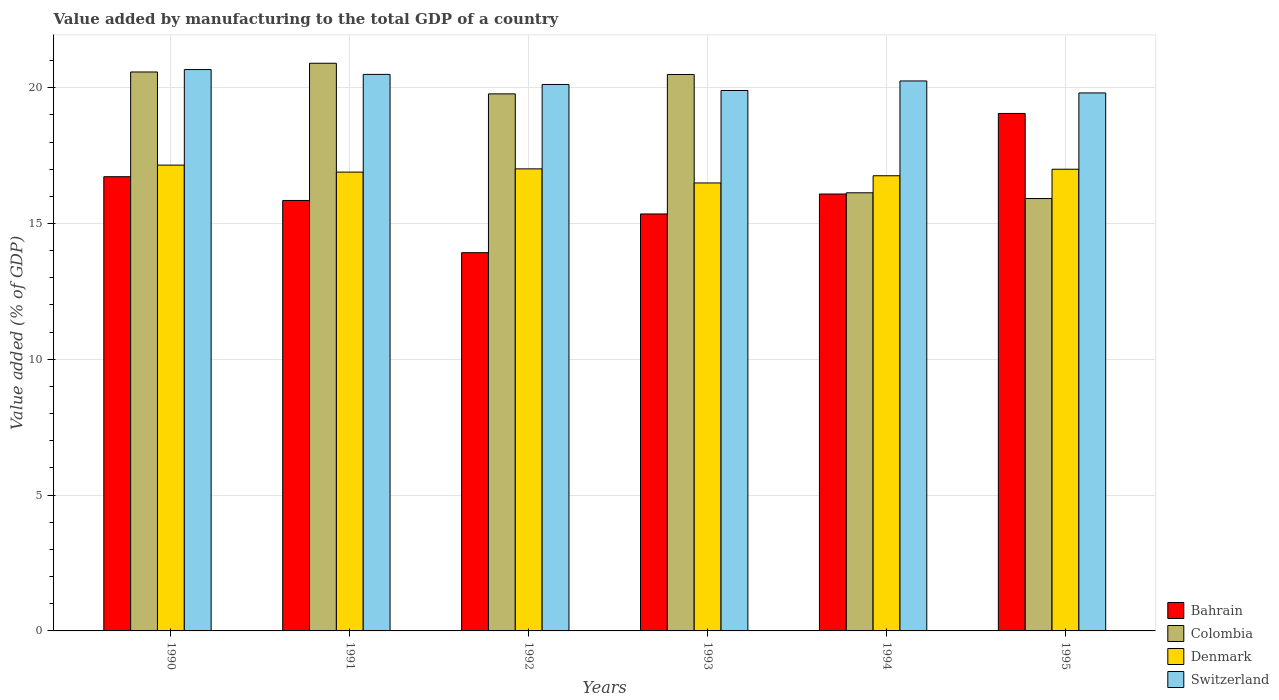Are the number of bars on each tick of the X-axis equal?
Offer a terse response. Yes. What is the label of the 4th group of bars from the left?
Provide a short and direct response. 1993. What is the value added by manufacturing to the total GDP in Denmark in 1990?
Your answer should be compact. 17.15. Across all years, what is the maximum value added by manufacturing to the total GDP in Switzerland?
Offer a terse response. 20.67. Across all years, what is the minimum value added by manufacturing to the total GDP in Switzerland?
Your response must be concise. 19.81. In which year was the value added by manufacturing to the total GDP in Colombia maximum?
Provide a succinct answer. 1991. In which year was the value added by manufacturing to the total GDP in Switzerland minimum?
Offer a very short reply. 1995. What is the total value added by manufacturing to the total GDP in Denmark in the graph?
Your response must be concise. 101.3. What is the difference between the value added by manufacturing to the total GDP in Colombia in 1990 and that in 1991?
Offer a very short reply. -0.32. What is the difference between the value added by manufacturing to the total GDP in Colombia in 1992 and the value added by manufacturing to the total GDP in Denmark in 1994?
Your response must be concise. 3.01. What is the average value added by manufacturing to the total GDP in Switzerland per year?
Make the answer very short. 20.21. In the year 1995, what is the difference between the value added by manufacturing to the total GDP in Denmark and value added by manufacturing to the total GDP in Colombia?
Offer a very short reply. 1.08. What is the ratio of the value added by manufacturing to the total GDP in Denmark in 1990 to that in 1994?
Provide a succinct answer. 1.02. Is the value added by manufacturing to the total GDP in Bahrain in 1990 less than that in 1993?
Make the answer very short. No. What is the difference between the highest and the second highest value added by manufacturing to the total GDP in Bahrain?
Offer a very short reply. 2.33. What is the difference between the highest and the lowest value added by manufacturing to the total GDP in Denmark?
Your answer should be very brief. 0.66. In how many years, is the value added by manufacturing to the total GDP in Bahrain greater than the average value added by manufacturing to the total GDP in Bahrain taken over all years?
Your answer should be compact. 2. Is the sum of the value added by manufacturing to the total GDP in Denmark in 1990 and 1993 greater than the maximum value added by manufacturing to the total GDP in Switzerland across all years?
Ensure brevity in your answer.  Yes. Is it the case that in every year, the sum of the value added by manufacturing to the total GDP in Colombia and value added by manufacturing to the total GDP in Switzerland is greater than the sum of value added by manufacturing to the total GDP in Denmark and value added by manufacturing to the total GDP in Bahrain?
Keep it short and to the point. No. What does the 1st bar from the left in 1991 represents?
Provide a short and direct response. Bahrain. What does the 1st bar from the right in 1992 represents?
Offer a terse response. Switzerland. Is it the case that in every year, the sum of the value added by manufacturing to the total GDP in Colombia and value added by manufacturing to the total GDP in Denmark is greater than the value added by manufacturing to the total GDP in Switzerland?
Offer a very short reply. Yes. How many bars are there?
Offer a very short reply. 24. How many years are there in the graph?
Make the answer very short. 6. Does the graph contain grids?
Ensure brevity in your answer.  Yes. What is the title of the graph?
Provide a short and direct response. Value added by manufacturing to the total GDP of a country. What is the label or title of the Y-axis?
Provide a succinct answer. Value added (% of GDP). What is the Value added (% of GDP) in Bahrain in 1990?
Your answer should be compact. 16.72. What is the Value added (% of GDP) in Colombia in 1990?
Keep it short and to the point. 20.58. What is the Value added (% of GDP) of Denmark in 1990?
Provide a short and direct response. 17.15. What is the Value added (% of GDP) of Switzerland in 1990?
Give a very brief answer. 20.67. What is the Value added (% of GDP) in Bahrain in 1991?
Provide a short and direct response. 15.85. What is the Value added (% of GDP) of Colombia in 1991?
Make the answer very short. 20.9. What is the Value added (% of GDP) in Denmark in 1991?
Your answer should be very brief. 16.89. What is the Value added (% of GDP) of Switzerland in 1991?
Your response must be concise. 20.49. What is the Value added (% of GDP) of Bahrain in 1992?
Offer a very short reply. 13.93. What is the Value added (% of GDP) of Colombia in 1992?
Keep it short and to the point. 19.77. What is the Value added (% of GDP) in Denmark in 1992?
Ensure brevity in your answer.  17.01. What is the Value added (% of GDP) of Switzerland in 1992?
Your answer should be very brief. 20.12. What is the Value added (% of GDP) of Bahrain in 1993?
Your answer should be very brief. 15.35. What is the Value added (% of GDP) in Colombia in 1993?
Offer a very short reply. 20.49. What is the Value added (% of GDP) of Denmark in 1993?
Ensure brevity in your answer.  16.49. What is the Value added (% of GDP) in Switzerland in 1993?
Your answer should be very brief. 19.9. What is the Value added (% of GDP) in Bahrain in 1994?
Your answer should be compact. 16.09. What is the Value added (% of GDP) of Colombia in 1994?
Provide a short and direct response. 16.13. What is the Value added (% of GDP) in Denmark in 1994?
Your response must be concise. 16.76. What is the Value added (% of GDP) of Switzerland in 1994?
Offer a very short reply. 20.25. What is the Value added (% of GDP) in Bahrain in 1995?
Keep it short and to the point. 19.05. What is the Value added (% of GDP) of Colombia in 1995?
Provide a short and direct response. 15.92. What is the Value added (% of GDP) in Denmark in 1995?
Ensure brevity in your answer.  17. What is the Value added (% of GDP) in Switzerland in 1995?
Provide a short and direct response. 19.81. Across all years, what is the maximum Value added (% of GDP) of Bahrain?
Provide a succinct answer. 19.05. Across all years, what is the maximum Value added (% of GDP) in Colombia?
Your response must be concise. 20.9. Across all years, what is the maximum Value added (% of GDP) in Denmark?
Your answer should be compact. 17.15. Across all years, what is the maximum Value added (% of GDP) of Switzerland?
Provide a succinct answer. 20.67. Across all years, what is the minimum Value added (% of GDP) in Bahrain?
Your answer should be compact. 13.93. Across all years, what is the minimum Value added (% of GDP) of Colombia?
Offer a very short reply. 15.92. Across all years, what is the minimum Value added (% of GDP) of Denmark?
Offer a very short reply. 16.49. Across all years, what is the minimum Value added (% of GDP) in Switzerland?
Your answer should be very brief. 19.81. What is the total Value added (% of GDP) of Bahrain in the graph?
Make the answer very short. 96.99. What is the total Value added (% of GDP) in Colombia in the graph?
Your response must be concise. 113.79. What is the total Value added (% of GDP) of Denmark in the graph?
Make the answer very short. 101.31. What is the total Value added (% of GDP) of Switzerland in the graph?
Your response must be concise. 121.23. What is the difference between the Value added (% of GDP) of Bahrain in 1990 and that in 1991?
Keep it short and to the point. 0.87. What is the difference between the Value added (% of GDP) in Colombia in 1990 and that in 1991?
Provide a short and direct response. -0.32. What is the difference between the Value added (% of GDP) in Denmark in 1990 and that in 1991?
Your answer should be compact. 0.26. What is the difference between the Value added (% of GDP) of Switzerland in 1990 and that in 1991?
Make the answer very short. 0.18. What is the difference between the Value added (% of GDP) in Bahrain in 1990 and that in 1992?
Provide a short and direct response. 2.8. What is the difference between the Value added (% of GDP) of Colombia in 1990 and that in 1992?
Make the answer very short. 0.81. What is the difference between the Value added (% of GDP) in Denmark in 1990 and that in 1992?
Your answer should be compact. 0.14. What is the difference between the Value added (% of GDP) in Switzerland in 1990 and that in 1992?
Ensure brevity in your answer.  0.55. What is the difference between the Value added (% of GDP) of Bahrain in 1990 and that in 1993?
Offer a very short reply. 1.37. What is the difference between the Value added (% of GDP) of Colombia in 1990 and that in 1993?
Provide a succinct answer. 0.09. What is the difference between the Value added (% of GDP) in Denmark in 1990 and that in 1993?
Provide a succinct answer. 0.66. What is the difference between the Value added (% of GDP) of Switzerland in 1990 and that in 1993?
Your response must be concise. 0.77. What is the difference between the Value added (% of GDP) of Bahrain in 1990 and that in 1994?
Provide a succinct answer. 0.64. What is the difference between the Value added (% of GDP) of Colombia in 1990 and that in 1994?
Offer a terse response. 4.45. What is the difference between the Value added (% of GDP) in Denmark in 1990 and that in 1994?
Give a very brief answer. 0.39. What is the difference between the Value added (% of GDP) in Switzerland in 1990 and that in 1994?
Ensure brevity in your answer.  0.42. What is the difference between the Value added (% of GDP) in Bahrain in 1990 and that in 1995?
Ensure brevity in your answer.  -2.33. What is the difference between the Value added (% of GDP) in Colombia in 1990 and that in 1995?
Keep it short and to the point. 4.66. What is the difference between the Value added (% of GDP) of Denmark in 1990 and that in 1995?
Your response must be concise. 0.15. What is the difference between the Value added (% of GDP) of Switzerland in 1990 and that in 1995?
Your answer should be compact. 0.86. What is the difference between the Value added (% of GDP) in Bahrain in 1991 and that in 1992?
Your response must be concise. 1.92. What is the difference between the Value added (% of GDP) of Colombia in 1991 and that in 1992?
Provide a succinct answer. 1.13. What is the difference between the Value added (% of GDP) of Denmark in 1991 and that in 1992?
Your response must be concise. -0.12. What is the difference between the Value added (% of GDP) in Switzerland in 1991 and that in 1992?
Your answer should be very brief. 0.37. What is the difference between the Value added (% of GDP) of Bahrain in 1991 and that in 1993?
Offer a very short reply. 0.5. What is the difference between the Value added (% of GDP) in Colombia in 1991 and that in 1993?
Give a very brief answer. 0.41. What is the difference between the Value added (% of GDP) in Denmark in 1991 and that in 1993?
Ensure brevity in your answer.  0.4. What is the difference between the Value added (% of GDP) in Switzerland in 1991 and that in 1993?
Provide a succinct answer. 0.59. What is the difference between the Value added (% of GDP) in Bahrain in 1991 and that in 1994?
Provide a short and direct response. -0.24. What is the difference between the Value added (% of GDP) in Colombia in 1991 and that in 1994?
Make the answer very short. 4.77. What is the difference between the Value added (% of GDP) of Denmark in 1991 and that in 1994?
Offer a terse response. 0.13. What is the difference between the Value added (% of GDP) in Switzerland in 1991 and that in 1994?
Provide a short and direct response. 0.24. What is the difference between the Value added (% of GDP) of Bahrain in 1991 and that in 1995?
Your answer should be compact. -3.2. What is the difference between the Value added (% of GDP) in Colombia in 1991 and that in 1995?
Provide a short and direct response. 4.98. What is the difference between the Value added (% of GDP) of Denmark in 1991 and that in 1995?
Make the answer very short. -0.11. What is the difference between the Value added (% of GDP) in Switzerland in 1991 and that in 1995?
Provide a short and direct response. 0.68. What is the difference between the Value added (% of GDP) of Bahrain in 1992 and that in 1993?
Give a very brief answer. -1.43. What is the difference between the Value added (% of GDP) of Colombia in 1992 and that in 1993?
Your response must be concise. -0.71. What is the difference between the Value added (% of GDP) in Denmark in 1992 and that in 1993?
Ensure brevity in your answer.  0.52. What is the difference between the Value added (% of GDP) in Switzerland in 1992 and that in 1993?
Offer a terse response. 0.22. What is the difference between the Value added (% of GDP) in Bahrain in 1992 and that in 1994?
Provide a short and direct response. -2.16. What is the difference between the Value added (% of GDP) of Colombia in 1992 and that in 1994?
Ensure brevity in your answer.  3.64. What is the difference between the Value added (% of GDP) in Denmark in 1992 and that in 1994?
Give a very brief answer. 0.25. What is the difference between the Value added (% of GDP) in Switzerland in 1992 and that in 1994?
Make the answer very short. -0.13. What is the difference between the Value added (% of GDP) of Bahrain in 1992 and that in 1995?
Your answer should be very brief. -5.13. What is the difference between the Value added (% of GDP) in Colombia in 1992 and that in 1995?
Give a very brief answer. 3.85. What is the difference between the Value added (% of GDP) in Denmark in 1992 and that in 1995?
Offer a very short reply. 0.01. What is the difference between the Value added (% of GDP) of Switzerland in 1992 and that in 1995?
Keep it short and to the point. 0.31. What is the difference between the Value added (% of GDP) in Bahrain in 1993 and that in 1994?
Your response must be concise. -0.73. What is the difference between the Value added (% of GDP) in Colombia in 1993 and that in 1994?
Provide a succinct answer. 4.36. What is the difference between the Value added (% of GDP) in Denmark in 1993 and that in 1994?
Provide a succinct answer. -0.26. What is the difference between the Value added (% of GDP) of Switzerland in 1993 and that in 1994?
Make the answer very short. -0.35. What is the difference between the Value added (% of GDP) of Bahrain in 1993 and that in 1995?
Your response must be concise. -3.7. What is the difference between the Value added (% of GDP) of Colombia in 1993 and that in 1995?
Offer a very short reply. 4.57. What is the difference between the Value added (% of GDP) of Denmark in 1993 and that in 1995?
Keep it short and to the point. -0.51. What is the difference between the Value added (% of GDP) in Switzerland in 1993 and that in 1995?
Keep it short and to the point. 0.09. What is the difference between the Value added (% of GDP) of Bahrain in 1994 and that in 1995?
Provide a succinct answer. -2.97. What is the difference between the Value added (% of GDP) of Colombia in 1994 and that in 1995?
Your response must be concise. 0.21. What is the difference between the Value added (% of GDP) in Denmark in 1994 and that in 1995?
Keep it short and to the point. -0.24. What is the difference between the Value added (% of GDP) of Switzerland in 1994 and that in 1995?
Your response must be concise. 0.44. What is the difference between the Value added (% of GDP) of Bahrain in 1990 and the Value added (% of GDP) of Colombia in 1991?
Your answer should be very brief. -4.18. What is the difference between the Value added (% of GDP) of Bahrain in 1990 and the Value added (% of GDP) of Denmark in 1991?
Your response must be concise. -0.17. What is the difference between the Value added (% of GDP) in Bahrain in 1990 and the Value added (% of GDP) in Switzerland in 1991?
Your answer should be compact. -3.77. What is the difference between the Value added (% of GDP) of Colombia in 1990 and the Value added (% of GDP) of Denmark in 1991?
Your answer should be compact. 3.69. What is the difference between the Value added (% of GDP) of Colombia in 1990 and the Value added (% of GDP) of Switzerland in 1991?
Your answer should be compact. 0.09. What is the difference between the Value added (% of GDP) of Denmark in 1990 and the Value added (% of GDP) of Switzerland in 1991?
Keep it short and to the point. -3.34. What is the difference between the Value added (% of GDP) of Bahrain in 1990 and the Value added (% of GDP) of Colombia in 1992?
Make the answer very short. -3.05. What is the difference between the Value added (% of GDP) in Bahrain in 1990 and the Value added (% of GDP) in Denmark in 1992?
Make the answer very short. -0.29. What is the difference between the Value added (% of GDP) of Bahrain in 1990 and the Value added (% of GDP) of Switzerland in 1992?
Your response must be concise. -3.4. What is the difference between the Value added (% of GDP) of Colombia in 1990 and the Value added (% of GDP) of Denmark in 1992?
Keep it short and to the point. 3.57. What is the difference between the Value added (% of GDP) in Colombia in 1990 and the Value added (% of GDP) in Switzerland in 1992?
Your response must be concise. 0.46. What is the difference between the Value added (% of GDP) in Denmark in 1990 and the Value added (% of GDP) in Switzerland in 1992?
Offer a very short reply. -2.97. What is the difference between the Value added (% of GDP) of Bahrain in 1990 and the Value added (% of GDP) of Colombia in 1993?
Provide a succinct answer. -3.76. What is the difference between the Value added (% of GDP) in Bahrain in 1990 and the Value added (% of GDP) in Denmark in 1993?
Keep it short and to the point. 0.23. What is the difference between the Value added (% of GDP) in Bahrain in 1990 and the Value added (% of GDP) in Switzerland in 1993?
Offer a terse response. -3.17. What is the difference between the Value added (% of GDP) of Colombia in 1990 and the Value added (% of GDP) of Denmark in 1993?
Provide a short and direct response. 4.09. What is the difference between the Value added (% of GDP) of Colombia in 1990 and the Value added (% of GDP) of Switzerland in 1993?
Give a very brief answer. 0.68. What is the difference between the Value added (% of GDP) of Denmark in 1990 and the Value added (% of GDP) of Switzerland in 1993?
Keep it short and to the point. -2.75. What is the difference between the Value added (% of GDP) in Bahrain in 1990 and the Value added (% of GDP) in Colombia in 1994?
Provide a short and direct response. 0.59. What is the difference between the Value added (% of GDP) of Bahrain in 1990 and the Value added (% of GDP) of Denmark in 1994?
Provide a succinct answer. -0.04. What is the difference between the Value added (% of GDP) in Bahrain in 1990 and the Value added (% of GDP) in Switzerland in 1994?
Your answer should be very brief. -3.53. What is the difference between the Value added (% of GDP) of Colombia in 1990 and the Value added (% of GDP) of Denmark in 1994?
Offer a very short reply. 3.82. What is the difference between the Value added (% of GDP) in Colombia in 1990 and the Value added (% of GDP) in Switzerland in 1994?
Your answer should be compact. 0.33. What is the difference between the Value added (% of GDP) of Denmark in 1990 and the Value added (% of GDP) of Switzerland in 1994?
Offer a terse response. -3.1. What is the difference between the Value added (% of GDP) of Bahrain in 1990 and the Value added (% of GDP) of Colombia in 1995?
Offer a terse response. 0.8. What is the difference between the Value added (% of GDP) in Bahrain in 1990 and the Value added (% of GDP) in Denmark in 1995?
Provide a succinct answer. -0.28. What is the difference between the Value added (% of GDP) in Bahrain in 1990 and the Value added (% of GDP) in Switzerland in 1995?
Your response must be concise. -3.08. What is the difference between the Value added (% of GDP) of Colombia in 1990 and the Value added (% of GDP) of Denmark in 1995?
Your answer should be very brief. 3.58. What is the difference between the Value added (% of GDP) in Colombia in 1990 and the Value added (% of GDP) in Switzerland in 1995?
Provide a succinct answer. 0.77. What is the difference between the Value added (% of GDP) of Denmark in 1990 and the Value added (% of GDP) of Switzerland in 1995?
Provide a short and direct response. -2.66. What is the difference between the Value added (% of GDP) in Bahrain in 1991 and the Value added (% of GDP) in Colombia in 1992?
Ensure brevity in your answer.  -3.92. What is the difference between the Value added (% of GDP) in Bahrain in 1991 and the Value added (% of GDP) in Denmark in 1992?
Provide a succinct answer. -1.16. What is the difference between the Value added (% of GDP) in Bahrain in 1991 and the Value added (% of GDP) in Switzerland in 1992?
Offer a very short reply. -4.27. What is the difference between the Value added (% of GDP) of Colombia in 1991 and the Value added (% of GDP) of Denmark in 1992?
Provide a succinct answer. 3.89. What is the difference between the Value added (% of GDP) of Colombia in 1991 and the Value added (% of GDP) of Switzerland in 1992?
Keep it short and to the point. 0.78. What is the difference between the Value added (% of GDP) of Denmark in 1991 and the Value added (% of GDP) of Switzerland in 1992?
Give a very brief answer. -3.23. What is the difference between the Value added (% of GDP) of Bahrain in 1991 and the Value added (% of GDP) of Colombia in 1993?
Your answer should be very brief. -4.64. What is the difference between the Value added (% of GDP) in Bahrain in 1991 and the Value added (% of GDP) in Denmark in 1993?
Make the answer very short. -0.64. What is the difference between the Value added (% of GDP) of Bahrain in 1991 and the Value added (% of GDP) of Switzerland in 1993?
Make the answer very short. -4.05. What is the difference between the Value added (% of GDP) in Colombia in 1991 and the Value added (% of GDP) in Denmark in 1993?
Ensure brevity in your answer.  4.41. What is the difference between the Value added (% of GDP) in Colombia in 1991 and the Value added (% of GDP) in Switzerland in 1993?
Ensure brevity in your answer.  1. What is the difference between the Value added (% of GDP) of Denmark in 1991 and the Value added (% of GDP) of Switzerland in 1993?
Ensure brevity in your answer.  -3. What is the difference between the Value added (% of GDP) in Bahrain in 1991 and the Value added (% of GDP) in Colombia in 1994?
Make the answer very short. -0.28. What is the difference between the Value added (% of GDP) in Bahrain in 1991 and the Value added (% of GDP) in Denmark in 1994?
Keep it short and to the point. -0.91. What is the difference between the Value added (% of GDP) in Bahrain in 1991 and the Value added (% of GDP) in Switzerland in 1994?
Offer a terse response. -4.4. What is the difference between the Value added (% of GDP) in Colombia in 1991 and the Value added (% of GDP) in Denmark in 1994?
Your answer should be compact. 4.14. What is the difference between the Value added (% of GDP) in Colombia in 1991 and the Value added (% of GDP) in Switzerland in 1994?
Keep it short and to the point. 0.65. What is the difference between the Value added (% of GDP) in Denmark in 1991 and the Value added (% of GDP) in Switzerland in 1994?
Your answer should be very brief. -3.36. What is the difference between the Value added (% of GDP) of Bahrain in 1991 and the Value added (% of GDP) of Colombia in 1995?
Your response must be concise. -0.07. What is the difference between the Value added (% of GDP) in Bahrain in 1991 and the Value added (% of GDP) in Denmark in 1995?
Offer a very short reply. -1.15. What is the difference between the Value added (% of GDP) of Bahrain in 1991 and the Value added (% of GDP) of Switzerland in 1995?
Make the answer very short. -3.96. What is the difference between the Value added (% of GDP) in Colombia in 1991 and the Value added (% of GDP) in Denmark in 1995?
Your response must be concise. 3.9. What is the difference between the Value added (% of GDP) of Colombia in 1991 and the Value added (% of GDP) of Switzerland in 1995?
Provide a short and direct response. 1.09. What is the difference between the Value added (% of GDP) of Denmark in 1991 and the Value added (% of GDP) of Switzerland in 1995?
Provide a short and direct response. -2.91. What is the difference between the Value added (% of GDP) in Bahrain in 1992 and the Value added (% of GDP) in Colombia in 1993?
Offer a very short reply. -6.56. What is the difference between the Value added (% of GDP) of Bahrain in 1992 and the Value added (% of GDP) of Denmark in 1993?
Your answer should be compact. -2.57. What is the difference between the Value added (% of GDP) of Bahrain in 1992 and the Value added (% of GDP) of Switzerland in 1993?
Provide a short and direct response. -5.97. What is the difference between the Value added (% of GDP) in Colombia in 1992 and the Value added (% of GDP) in Denmark in 1993?
Provide a short and direct response. 3.28. What is the difference between the Value added (% of GDP) of Colombia in 1992 and the Value added (% of GDP) of Switzerland in 1993?
Offer a terse response. -0.12. What is the difference between the Value added (% of GDP) of Denmark in 1992 and the Value added (% of GDP) of Switzerland in 1993?
Provide a short and direct response. -2.89. What is the difference between the Value added (% of GDP) of Bahrain in 1992 and the Value added (% of GDP) of Colombia in 1994?
Offer a terse response. -2.21. What is the difference between the Value added (% of GDP) of Bahrain in 1992 and the Value added (% of GDP) of Denmark in 1994?
Offer a terse response. -2.83. What is the difference between the Value added (% of GDP) in Bahrain in 1992 and the Value added (% of GDP) in Switzerland in 1994?
Provide a succinct answer. -6.32. What is the difference between the Value added (% of GDP) in Colombia in 1992 and the Value added (% of GDP) in Denmark in 1994?
Ensure brevity in your answer.  3.01. What is the difference between the Value added (% of GDP) in Colombia in 1992 and the Value added (% of GDP) in Switzerland in 1994?
Keep it short and to the point. -0.48. What is the difference between the Value added (% of GDP) in Denmark in 1992 and the Value added (% of GDP) in Switzerland in 1994?
Ensure brevity in your answer.  -3.24. What is the difference between the Value added (% of GDP) of Bahrain in 1992 and the Value added (% of GDP) of Colombia in 1995?
Make the answer very short. -1.99. What is the difference between the Value added (% of GDP) of Bahrain in 1992 and the Value added (% of GDP) of Denmark in 1995?
Your response must be concise. -3.07. What is the difference between the Value added (% of GDP) in Bahrain in 1992 and the Value added (% of GDP) in Switzerland in 1995?
Your answer should be very brief. -5.88. What is the difference between the Value added (% of GDP) in Colombia in 1992 and the Value added (% of GDP) in Denmark in 1995?
Provide a succinct answer. 2.77. What is the difference between the Value added (% of GDP) of Colombia in 1992 and the Value added (% of GDP) of Switzerland in 1995?
Keep it short and to the point. -0.03. What is the difference between the Value added (% of GDP) in Denmark in 1992 and the Value added (% of GDP) in Switzerland in 1995?
Your answer should be very brief. -2.8. What is the difference between the Value added (% of GDP) of Bahrain in 1993 and the Value added (% of GDP) of Colombia in 1994?
Your answer should be very brief. -0.78. What is the difference between the Value added (% of GDP) in Bahrain in 1993 and the Value added (% of GDP) in Denmark in 1994?
Provide a succinct answer. -1.41. What is the difference between the Value added (% of GDP) in Bahrain in 1993 and the Value added (% of GDP) in Switzerland in 1994?
Your answer should be very brief. -4.9. What is the difference between the Value added (% of GDP) of Colombia in 1993 and the Value added (% of GDP) of Denmark in 1994?
Offer a very short reply. 3.73. What is the difference between the Value added (% of GDP) of Colombia in 1993 and the Value added (% of GDP) of Switzerland in 1994?
Give a very brief answer. 0.24. What is the difference between the Value added (% of GDP) of Denmark in 1993 and the Value added (% of GDP) of Switzerland in 1994?
Make the answer very short. -3.76. What is the difference between the Value added (% of GDP) of Bahrain in 1993 and the Value added (% of GDP) of Colombia in 1995?
Your answer should be compact. -0.57. What is the difference between the Value added (% of GDP) of Bahrain in 1993 and the Value added (% of GDP) of Denmark in 1995?
Your answer should be very brief. -1.65. What is the difference between the Value added (% of GDP) in Bahrain in 1993 and the Value added (% of GDP) in Switzerland in 1995?
Offer a very short reply. -4.46. What is the difference between the Value added (% of GDP) in Colombia in 1993 and the Value added (% of GDP) in Denmark in 1995?
Your answer should be very brief. 3.49. What is the difference between the Value added (% of GDP) in Colombia in 1993 and the Value added (% of GDP) in Switzerland in 1995?
Provide a succinct answer. 0.68. What is the difference between the Value added (% of GDP) in Denmark in 1993 and the Value added (% of GDP) in Switzerland in 1995?
Offer a terse response. -3.31. What is the difference between the Value added (% of GDP) of Bahrain in 1994 and the Value added (% of GDP) of Colombia in 1995?
Give a very brief answer. 0.17. What is the difference between the Value added (% of GDP) of Bahrain in 1994 and the Value added (% of GDP) of Denmark in 1995?
Provide a short and direct response. -0.91. What is the difference between the Value added (% of GDP) in Bahrain in 1994 and the Value added (% of GDP) in Switzerland in 1995?
Offer a terse response. -3.72. What is the difference between the Value added (% of GDP) of Colombia in 1994 and the Value added (% of GDP) of Denmark in 1995?
Your answer should be very brief. -0.87. What is the difference between the Value added (% of GDP) in Colombia in 1994 and the Value added (% of GDP) in Switzerland in 1995?
Provide a succinct answer. -3.68. What is the difference between the Value added (% of GDP) of Denmark in 1994 and the Value added (% of GDP) of Switzerland in 1995?
Offer a very short reply. -3.05. What is the average Value added (% of GDP) in Bahrain per year?
Your answer should be compact. 16.16. What is the average Value added (% of GDP) of Colombia per year?
Offer a very short reply. 18.96. What is the average Value added (% of GDP) in Denmark per year?
Offer a terse response. 16.88. What is the average Value added (% of GDP) of Switzerland per year?
Offer a terse response. 20.21. In the year 1990, what is the difference between the Value added (% of GDP) of Bahrain and Value added (% of GDP) of Colombia?
Your answer should be compact. -3.86. In the year 1990, what is the difference between the Value added (% of GDP) of Bahrain and Value added (% of GDP) of Denmark?
Provide a short and direct response. -0.43. In the year 1990, what is the difference between the Value added (% of GDP) in Bahrain and Value added (% of GDP) in Switzerland?
Provide a succinct answer. -3.95. In the year 1990, what is the difference between the Value added (% of GDP) in Colombia and Value added (% of GDP) in Denmark?
Your response must be concise. 3.43. In the year 1990, what is the difference between the Value added (% of GDP) in Colombia and Value added (% of GDP) in Switzerland?
Make the answer very short. -0.09. In the year 1990, what is the difference between the Value added (% of GDP) of Denmark and Value added (% of GDP) of Switzerland?
Your response must be concise. -3.52. In the year 1991, what is the difference between the Value added (% of GDP) of Bahrain and Value added (% of GDP) of Colombia?
Your answer should be very brief. -5.05. In the year 1991, what is the difference between the Value added (% of GDP) in Bahrain and Value added (% of GDP) in Denmark?
Provide a succinct answer. -1.04. In the year 1991, what is the difference between the Value added (% of GDP) of Bahrain and Value added (% of GDP) of Switzerland?
Offer a terse response. -4.64. In the year 1991, what is the difference between the Value added (% of GDP) of Colombia and Value added (% of GDP) of Denmark?
Your response must be concise. 4.01. In the year 1991, what is the difference between the Value added (% of GDP) of Colombia and Value added (% of GDP) of Switzerland?
Your answer should be very brief. 0.41. In the year 1991, what is the difference between the Value added (% of GDP) of Denmark and Value added (% of GDP) of Switzerland?
Offer a terse response. -3.6. In the year 1992, what is the difference between the Value added (% of GDP) of Bahrain and Value added (% of GDP) of Colombia?
Your answer should be very brief. -5.85. In the year 1992, what is the difference between the Value added (% of GDP) of Bahrain and Value added (% of GDP) of Denmark?
Provide a short and direct response. -3.09. In the year 1992, what is the difference between the Value added (% of GDP) of Bahrain and Value added (% of GDP) of Switzerland?
Give a very brief answer. -6.19. In the year 1992, what is the difference between the Value added (% of GDP) of Colombia and Value added (% of GDP) of Denmark?
Ensure brevity in your answer.  2.76. In the year 1992, what is the difference between the Value added (% of GDP) in Colombia and Value added (% of GDP) in Switzerland?
Provide a succinct answer. -0.35. In the year 1992, what is the difference between the Value added (% of GDP) in Denmark and Value added (% of GDP) in Switzerland?
Keep it short and to the point. -3.11. In the year 1993, what is the difference between the Value added (% of GDP) of Bahrain and Value added (% of GDP) of Colombia?
Keep it short and to the point. -5.14. In the year 1993, what is the difference between the Value added (% of GDP) of Bahrain and Value added (% of GDP) of Denmark?
Keep it short and to the point. -1.14. In the year 1993, what is the difference between the Value added (% of GDP) of Bahrain and Value added (% of GDP) of Switzerland?
Make the answer very short. -4.55. In the year 1993, what is the difference between the Value added (% of GDP) in Colombia and Value added (% of GDP) in Denmark?
Your response must be concise. 3.99. In the year 1993, what is the difference between the Value added (% of GDP) of Colombia and Value added (% of GDP) of Switzerland?
Keep it short and to the point. 0.59. In the year 1993, what is the difference between the Value added (% of GDP) of Denmark and Value added (% of GDP) of Switzerland?
Provide a succinct answer. -3.4. In the year 1994, what is the difference between the Value added (% of GDP) of Bahrain and Value added (% of GDP) of Colombia?
Offer a very short reply. -0.04. In the year 1994, what is the difference between the Value added (% of GDP) of Bahrain and Value added (% of GDP) of Denmark?
Make the answer very short. -0.67. In the year 1994, what is the difference between the Value added (% of GDP) in Bahrain and Value added (% of GDP) in Switzerland?
Your answer should be compact. -4.16. In the year 1994, what is the difference between the Value added (% of GDP) in Colombia and Value added (% of GDP) in Denmark?
Your response must be concise. -0.63. In the year 1994, what is the difference between the Value added (% of GDP) in Colombia and Value added (% of GDP) in Switzerland?
Keep it short and to the point. -4.12. In the year 1994, what is the difference between the Value added (% of GDP) in Denmark and Value added (% of GDP) in Switzerland?
Make the answer very short. -3.49. In the year 1995, what is the difference between the Value added (% of GDP) of Bahrain and Value added (% of GDP) of Colombia?
Keep it short and to the point. 3.13. In the year 1995, what is the difference between the Value added (% of GDP) of Bahrain and Value added (% of GDP) of Denmark?
Make the answer very short. 2.05. In the year 1995, what is the difference between the Value added (% of GDP) in Bahrain and Value added (% of GDP) in Switzerland?
Offer a very short reply. -0.76. In the year 1995, what is the difference between the Value added (% of GDP) of Colombia and Value added (% of GDP) of Denmark?
Your response must be concise. -1.08. In the year 1995, what is the difference between the Value added (% of GDP) in Colombia and Value added (% of GDP) in Switzerland?
Provide a succinct answer. -3.89. In the year 1995, what is the difference between the Value added (% of GDP) of Denmark and Value added (% of GDP) of Switzerland?
Make the answer very short. -2.81. What is the ratio of the Value added (% of GDP) in Bahrain in 1990 to that in 1991?
Make the answer very short. 1.06. What is the ratio of the Value added (% of GDP) of Colombia in 1990 to that in 1991?
Provide a short and direct response. 0.98. What is the ratio of the Value added (% of GDP) of Denmark in 1990 to that in 1991?
Offer a very short reply. 1.02. What is the ratio of the Value added (% of GDP) in Switzerland in 1990 to that in 1991?
Make the answer very short. 1.01. What is the ratio of the Value added (% of GDP) of Bahrain in 1990 to that in 1992?
Keep it short and to the point. 1.2. What is the ratio of the Value added (% of GDP) of Colombia in 1990 to that in 1992?
Offer a terse response. 1.04. What is the ratio of the Value added (% of GDP) of Switzerland in 1990 to that in 1992?
Offer a very short reply. 1.03. What is the ratio of the Value added (% of GDP) in Bahrain in 1990 to that in 1993?
Make the answer very short. 1.09. What is the ratio of the Value added (% of GDP) of Colombia in 1990 to that in 1993?
Your answer should be very brief. 1. What is the ratio of the Value added (% of GDP) in Denmark in 1990 to that in 1993?
Provide a succinct answer. 1.04. What is the ratio of the Value added (% of GDP) of Switzerland in 1990 to that in 1993?
Provide a short and direct response. 1.04. What is the ratio of the Value added (% of GDP) in Bahrain in 1990 to that in 1994?
Give a very brief answer. 1.04. What is the ratio of the Value added (% of GDP) of Colombia in 1990 to that in 1994?
Offer a terse response. 1.28. What is the ratio of the Value added (% of GDP) of Denmark in 1990 to that in 1994?
Provide a succinct answer. 1.02. What is the ratio of the Value added (% of GDP) of Switzerland in 1990 to that in 1994?
Your response must be concise. 1.02. What is the ratio of the Value added (% of GDP) of Bahrain in 1990 to that in 1995?
Your response must be concise. 0.88. What is the ratio of the Value added (% of GDP) of Colombia in 1990 to that in 1995?
Your response must be concise. 1.29. What is the ratio of the Value added (% of GDP) of Denmark in 1990 to that in 1995?
Your answer should be very brief. 1.01. What is the ratio of the Value added (% of GDP) of Switzerland in 1990 to that in 1995?
Give a very brief answer. 1.04. What is the ratio of the Value added (% of GDP) in Bahrain in 1991 to that in 1992?
Your response must be concise. 1.14. What is the ratio of the Value added (% of GDP) in Colombia in 1991 to that in 1992?
Offer a very short reply. 1.06. What is the ratio of the Value added (% of GDP) of Denmark in 1991 to that in 1992?
Your answer should be compact. 0.99. What is the ratio of the Value added (% of GDP) in Switzerland in 1991 to that in 1992?
Provide a succinct answer. 1.02. What is the ratio of the Value added (% of GDP) of Bahrain in 1991 to that in 1993?
Keep it short and to the point. 1.03. What is the ratio of the Value added (% of GDP) in Colombia in 1991 to that in 1993?
Keep it short and to the point. 1.02. What is the ratio of the Value added (% of GDP) in Denmark in 1991 to that in 1993?
Offer a very short reply. 1.02. What is the ratio of the Value added (% of GDP) of Switzerland in 1991 to that in 1993?
Offer a very short reply. 1.03. What is the ratio of the Value added (% of GDP) in Bahrain in 1991 to that in 1994?
Your answer should be compact. 0.99. What is the ratio of the Value added (% of GDP) of Colombia in 1991 to that in 1994?
Keep it short and to the point. 1.3. What is the ratio of the Value added (% of GDP) of Bahrain in 1991 to that in 1995?
Make the answer very short. 0.83. What is the ratio of the Value added (% of GDP) in Colombia in 1991 to that in 1995?
Your answer should be very brief. 1.31. What is the ratio of the Value added (% of GDP) of Switzerland in 1991 to that in 1995?
Your answer should be very brief. 1.03. What is the ratio of the Value added (% of GDP) of Bahrain in 1992 to that in 1993?
Offer a terse response. 0.91. What is the ratio of the Value added (% of GDP) of Colombia in 1992 to that in 1993?
Offer a terse response. 0.97. What is the ratio of the Value added (% of GDP) in Denmark in 1992 to that in 1993?
Your answer should be compact. 1.03. What is the ratio of the Value added (% of GDP) of Switzerland in 1992 to that in 1993?
Give a very brief answer. 1.01. What is the ratio of the Value added (% of GDP) in Bahrain in 1992 to that in 1994?
Offer a very short reply. 0.87. What is the ratio of the Value added (% of GDP) of Colombia in 1992 to that in 1994?
Your response must be concise. 1.23. What is the ratio of the Value added (% of GDP) of Denmark in 1992 to that in 1994?
Your response must be concise. 1.02. What is the ratio of the Value added (% of GDP) of Switzerland in 1992 to that in 1994?
Your answer should be compact. 0.99. What is the ratio of the Value added (% of GDP) of Bahrain in 1992 to that in 1995?
Offer a terse response. 0.73. What is the ratio of the Value added (% of GDP) of Colombia in 1992 to that in 1995?
Offer a very short reply. 1.24. What is the ratio of the Value added (% of GDP) in Denmark in 1992 to that in 1995?
Make the answer very short. 1. What is the ratio of the Value added (% of GDP) of Switzerland in 1992 to that in 1995?
Your response must be concise. 1.02. What is the ratio of the Value added (% of GDP) of Bahrain in 1993 to that in 1994?
Ensure brevity in your answer.  0.95. What is the ratio of the Value added (% of GDP) in Colombia in 1993 to that in 1994?
Provide a succinct answer. 1.27. What is the ratio of the Value added (% of GDP) of Denmark in 1993 to that in 1994?
Your answer should be compact. 0.98. What is the ratio of the Value added (% of GDP) of Switzerland in 1993 to that in 1994?
Provide a short and direct response. 0.98. What is the ratio of the Value added (% of GDP) of Bahrain in 1993 to that in 1995?
Provide a succinct answer. 0.81. What is the ratio of the Value added (% of GDP) in Colombia in 1993 to that in 1995?
Make the answer very short. 1.29. What is the ratio of the Value added (% of GDP) in Denmark in 1993 to that in 1995?
Your answer should be compact. 0.97. What is the ratio of the Value added (% of GDP) of Bahrain in 1994 to that in 1995?
Offer a very short reply. 0.84. What is the ratio of the Value added (% of GDP) in Colombia in 1994 to that in 1995?
Provide a short and direct response. 1.01. What is the ratio of the Value added (% of GDP) in Denmark in 1994 to that in 1995?
Your answer should be very brief. 0.99. What is the ratio of the Value added (% of GDP) of Switzerland in 1994 to that in 1995?
Keep it short and to the point. 1.02. What is the difference between the highest and the second highest Value added (% of GDP) of Bahrain?
Give a very brief answer. 2.33. What is the difference between the highest and the second highest Value added (% of GDP) in Colombia?
Provide a succinct answer. 0.32. What is the difference between the highest and the second highest Value added (% of GDP) of Denmark?
Provide a short and direct response. 0.14. What is the difference between the highest and the second highest Value added (% of GDP) in Switzerland?
Provide a succinct answer. 0.18. What is the difference between the highest and the lowest Value added (% of GDP) in Bahrain?
Ensure brevity in your answer.  5.13. What is the difference between the highest and the lowest Value added (% of GDP) of Colombia?
Offer a very short reply. 4.98. What is the difference between the highest and the lowest Value added (% of GDP) of Denmark?
Your answer should be compact. 0.66. What is the difference between the highest and the lowest Value added (% of GDP) of Switzerland?
Offer a very short reply. 0.86. 